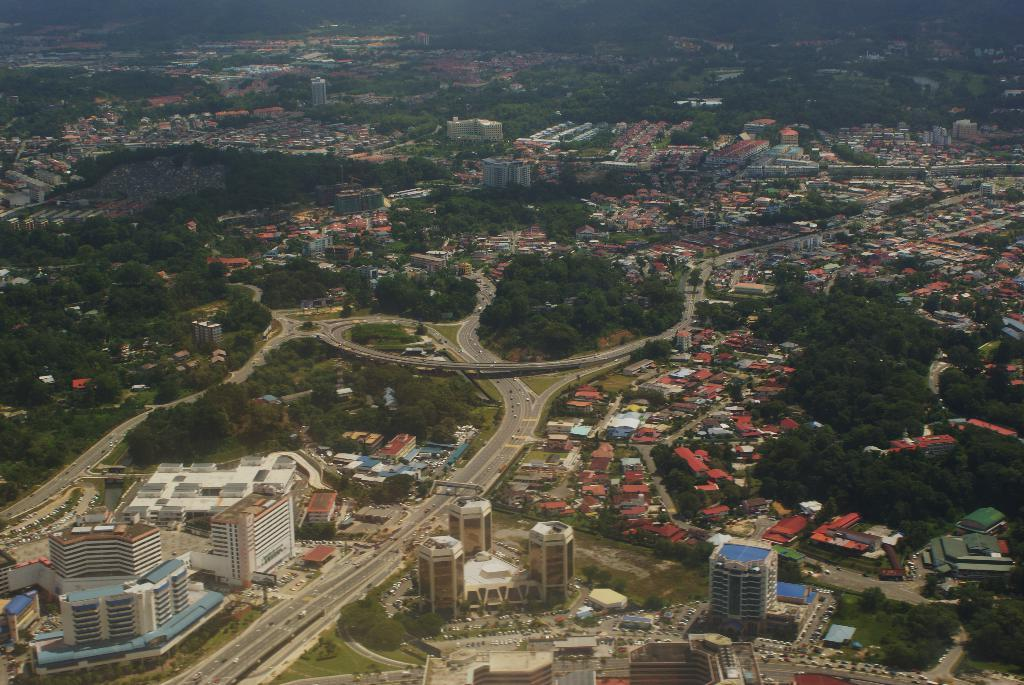What type of structures can be seen in the image? There are buildings in the image. What natural elements are present in the image? There are trees in the image. What man-made objects can be seen in the image? There are vehicles in the image. What transportation-related features can be seen in the background of the image? In the background, there is a train and a bridge visible. What type of yam is being cooked in the stew in the image? There is no yam or stew present in the image. Can you describe the mother's interaction with the buildings in the image? There is no mother present in the image, so it is not possible to describe any interaction with the buildings. 